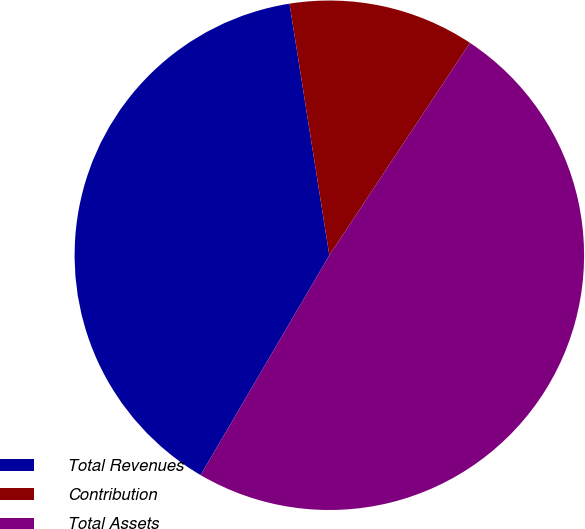Convert chart to OTSL. <chart><loc_0><loc_0><loc_500><loc_500><pie_chart><fcel>Total Revenues<fcel>Contribution<fcel>Total Assets<nl><fcel>39.07%<fcel>11.81%<fcel>49.12%<nl></chart> 